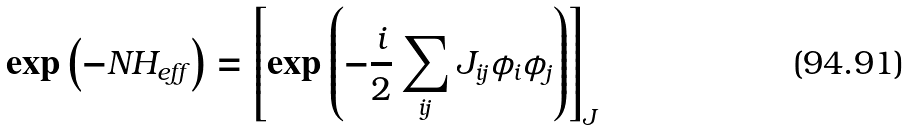Convert formula to latex. <formula><loc_0><loc_0><loc_500><loc_500>\exp \left ( - N H _ { e f f } \right ) = \left [ \exp \left ( - \frac { i } { 2 } \sum _ { i j } J _ { i j } \phi _ { i } \phi _ { j } \right ) \right ] _ { J }</formula> 